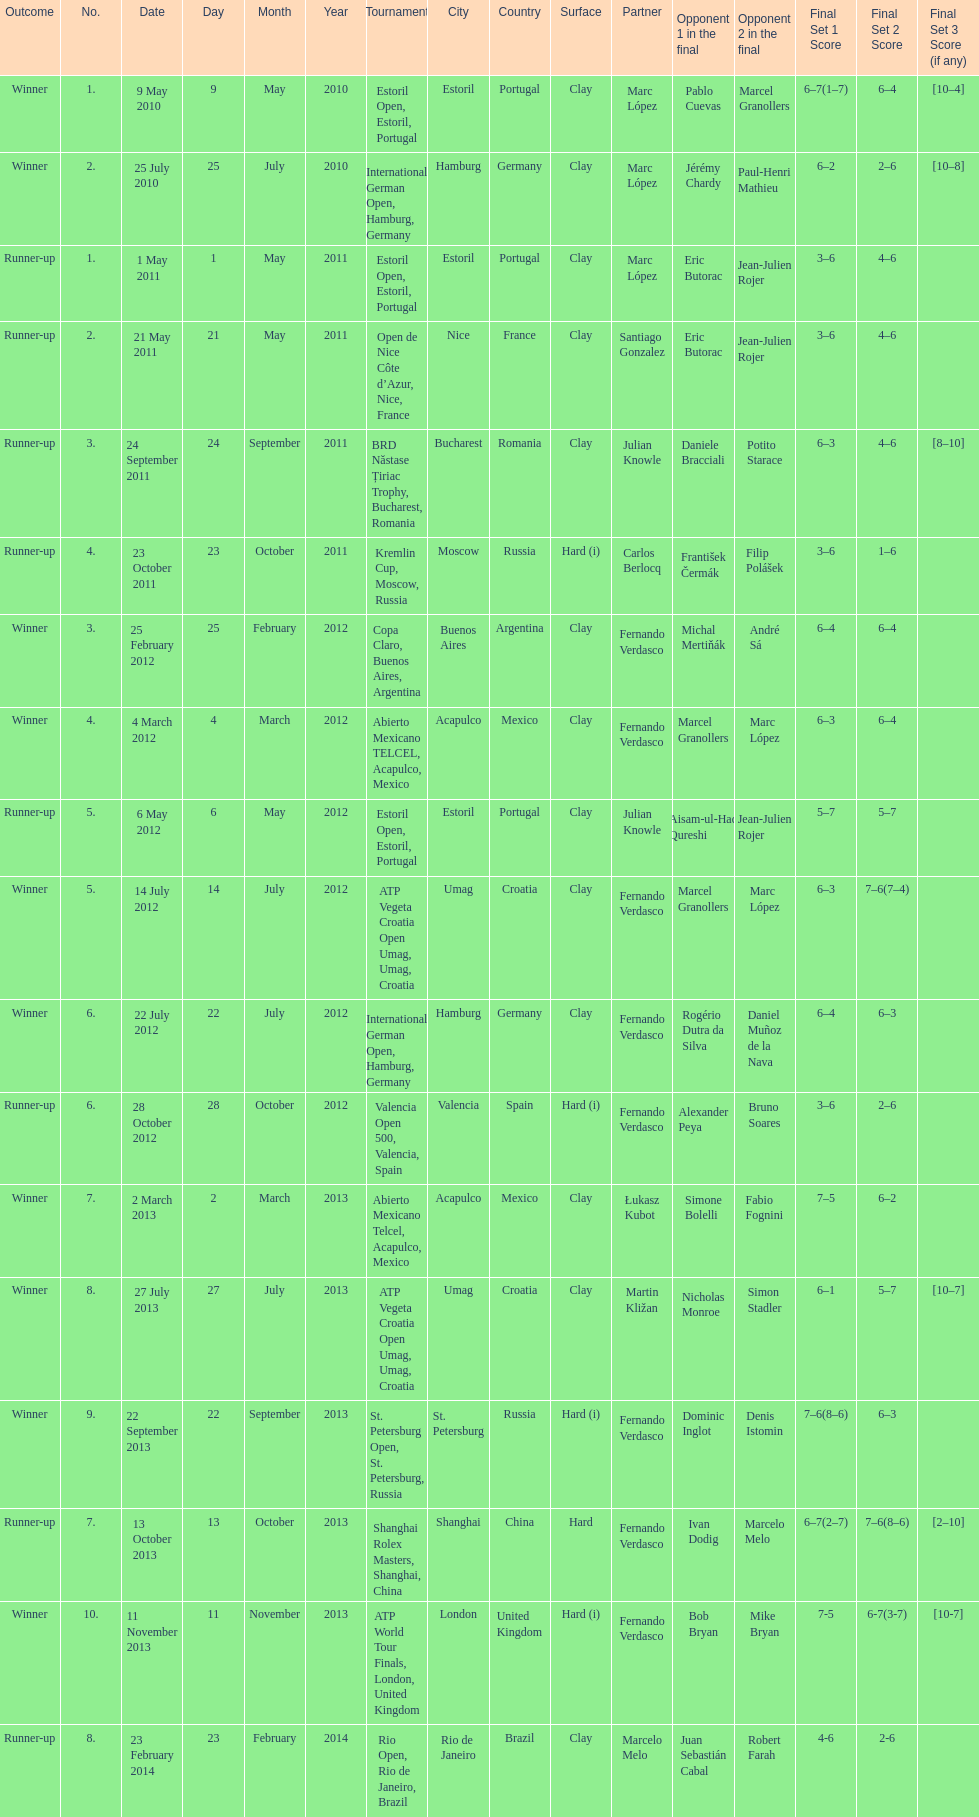Who won both the st.petersburg open and the atp world tour finals? Fernando Verdasco. 